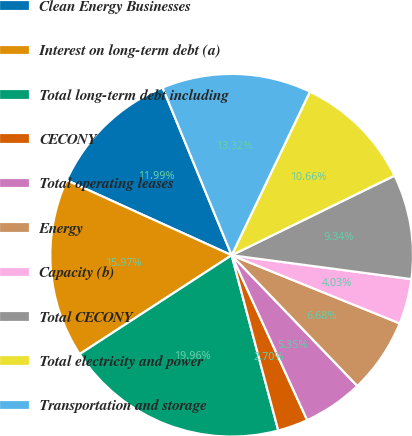Convert chart. <chart><loc_0><loc_0><loc_500><loc_500><pie_chart><fcel>Clean Energy Businesses<fcel>Interest on long-term debt (a)<fcel>Total long-term debt including<fcel>CECONY<fcel>Total operating leases<fcel>Energy<fcel>Capacity (b)<fcel>Total CECONY<fcel>Total electricity and power<fcel>Transportation and storage<nl><fcel>11.99%<fcel>15.97%<fcel>19.96%<fcel>2.7%<fcel>5.35%<fcel>6.68%<fcel>4.03%<fcel>9.34%<fcel>10.66%<fcel>13.32%<nl></chart> 